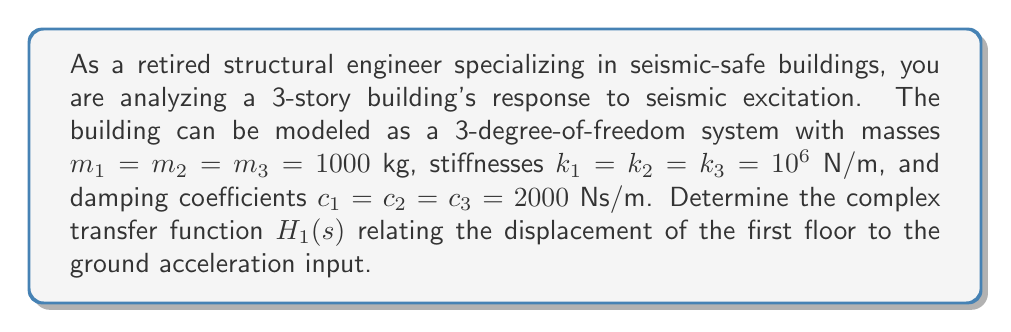Could you help me with this problem? To solve this problem, we'll follow these steps:

1) First, we need to set up the equations of motion for the 3-DOF system.
2) Then, we'll transform these equations into the Laplace domain.
3) Finally, we'll solve for the transfer function $H_1(s)$.

Step 1: Equations of motion

The equations of motion for a 3-DOF system are:

$$m_1\ddot{x}_1 + c_1(\dot{x}_1-\dot{x}_0) + c_2(\dot{x}_1-\dot{x}_2) + k_1(x_1-x_0) + k_2(x_1-x_2) = 0$$
$$m_2\ddot{x}_2 + c_2(\dot{x}_2-\dot{x}_1) + c_3(\dot{x}_2-\dot{x}_3) + k_2(x_2-x_1) + k_3(x_2-x_3) = 0$$
$$m_3\ddot{x}_3 + c_3(\dot{x}_3-\dot{x}_2) + k_3(x_3-x_2) = 0$$

Where $x_0$ is the ground displacement.

Step 2: Laplace transform

Applying the Laplace transform and assuming zero initial conditions:

$$(m_1s^2 + (c_1+c_2)s + (k_1+k_2))X_1(s) - (c_2s + k_2)X_2(s) = (c_1s + k_1)X_0(s)$$
$$-(c_2s + k_2)X_1(s) + (m_2s^2 + (c_2+c_3)s + (k_2+k_3))X_2(s) - (c_3s + k_3)X_3(s) = 0$$
$$-(c_3s + k_3)X_2(s) + (m_3s^2 + c_3s + k_3)X_3(s) = 0$$

Step 3: Solve for transfer function

The transfer function $H_1(s)$ is defined as $X_1(s)/\ddot{X}_0(s)$, where $\ddot{X}_0(s) = s^2X_0(s)$.

Let's define:

$$a = m_1s^2 + (c_1+c_2)s + (k_1+k_2)$$
$$b = -(c_2s + k_2)$$
$$c = m_2s^2 + (c_2+c_3)s + (k_2+k_3)$$
$$d = -(c_3s + k_3)$$
$$e = m_3s^2 + c_3s + k_3$$
$$f = c_1s + k_1$$

Now we can write the system in matrix form:

$$\begin{bmatrix} 
a & b & 0 \\
b & c & d \\
0 & d & e
\end{bmatrix}
\begin{bmatrix}
X_1(s) \\
X_2(s) \\
X_3(s)
\end{bmatrix} =
\begin{bmatrix}
fX_0(s) \\
0 \\
0
\end{bmatrix}$$

Using Cramer's rule:

$$H_1(s) = \frac{X_1(s)}{\ddot{X}_0(s)} = \frac{1}{s^2} \cdot \frac{\begin{vmatrix}
f & b & 0 \\
0 & c & d \\
0 & d & e
\end{vmatrix}}{\begin{vmatrix}
a & b & 0 \\
b & c & d \\
0 & d & e
\end{vmatrix}}$$

Evaluating the determinants:

$$H_1(s) = \frac{1}{s^2} \cdot \frac{f(ce-d^2)}{a(ce-d^2) - b^2e}$$

Substituting the values:

$$H_1(s) = \frac{(c_1s + k_1)(m_2m_3s^4 + (m_2c_3+m_3c_2+m_3c_3)s^3 + (m_2k_3+m_3k_2+m_3k_3)s^2)}{s^2(m_1m_2m_3s^6 + (...) s^5 + (...) s^4 + (...) s^3 + (...) s^2 + (...) s + k_1k_2k_3)}$$

Where (...) represents complex polynomial coefficients.
Answer: The complex transfer function $H_1(s)$ relating the displacement of the first floor to the ground acceleration input is:

$$H_1(s) = \frac{(2000s + 10^6)(10^6s^4 + 4 \times 10^6s^3 + 3 \times 10^9s^2)}{s^2(10^9s^6 + (...) s^5 + (...) s^4 + (...) s^3 + (...) s^2 + (...) s + 10^{18})}$$

Where (...) represents complex polynomial coefficients that depend on the mass, stiffness, and damping parameters of the system. 